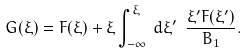<formula> <loc_0><loc_0><loc_500><loc_500>G ( \xi ) = F ( \xi ) + \xi \int _ { - \infty } ^ { \xi } \, d \xi ^ { \prime } \ \frac { \xi ^ { \prime } F ( \xi ^ { \prime } ) } { B _ { 1 } } .</formula> 